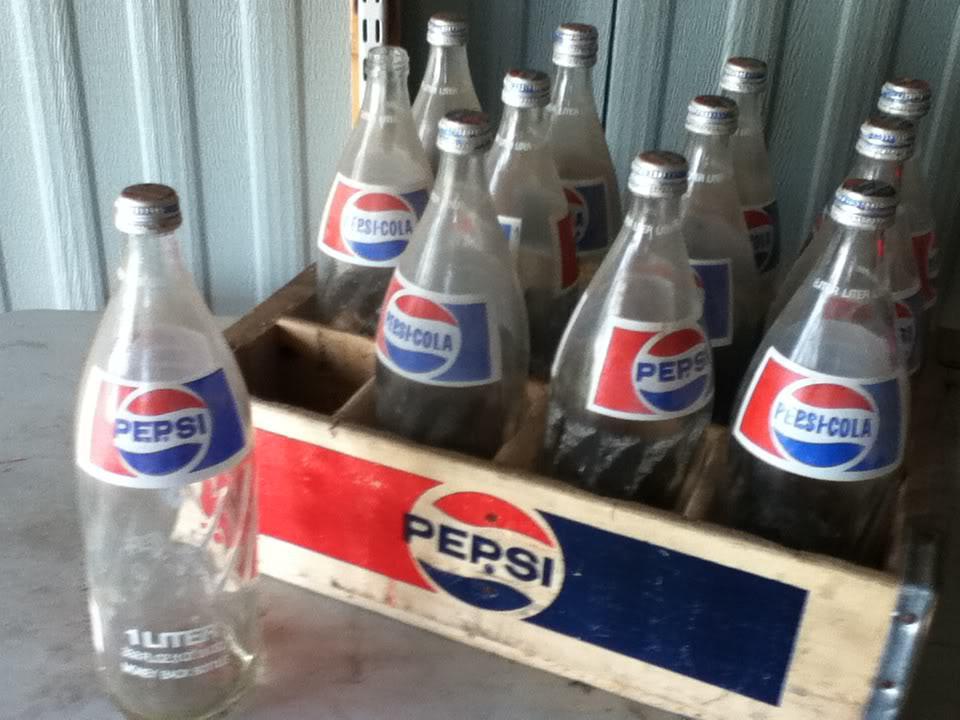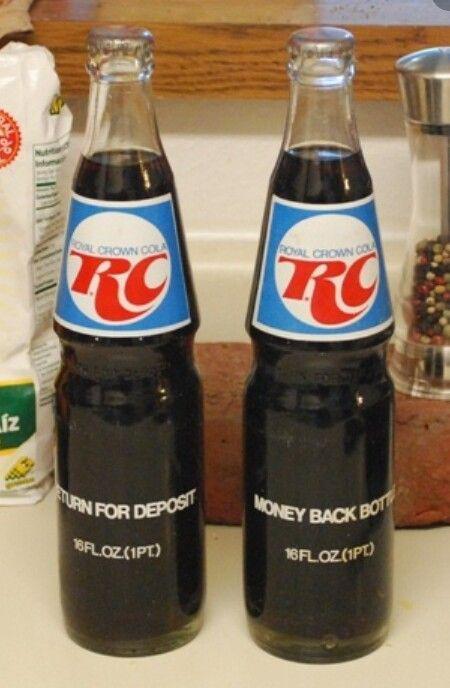The first image is the image on the left, the second image is the image on the right. Assess this claim about the two images: "The left and right images each feature a single soda bottle with its cap on, and the bottles on the left and right contain the same amount of soda and have similar but not identical labels.". Correct or not? Answer yes or no. No. The first image is the image on the left, the second image is the image on the right. Given the left and right images, does the statement "Pepsi brand is present." hold true? Answer yes or no. Yes. 